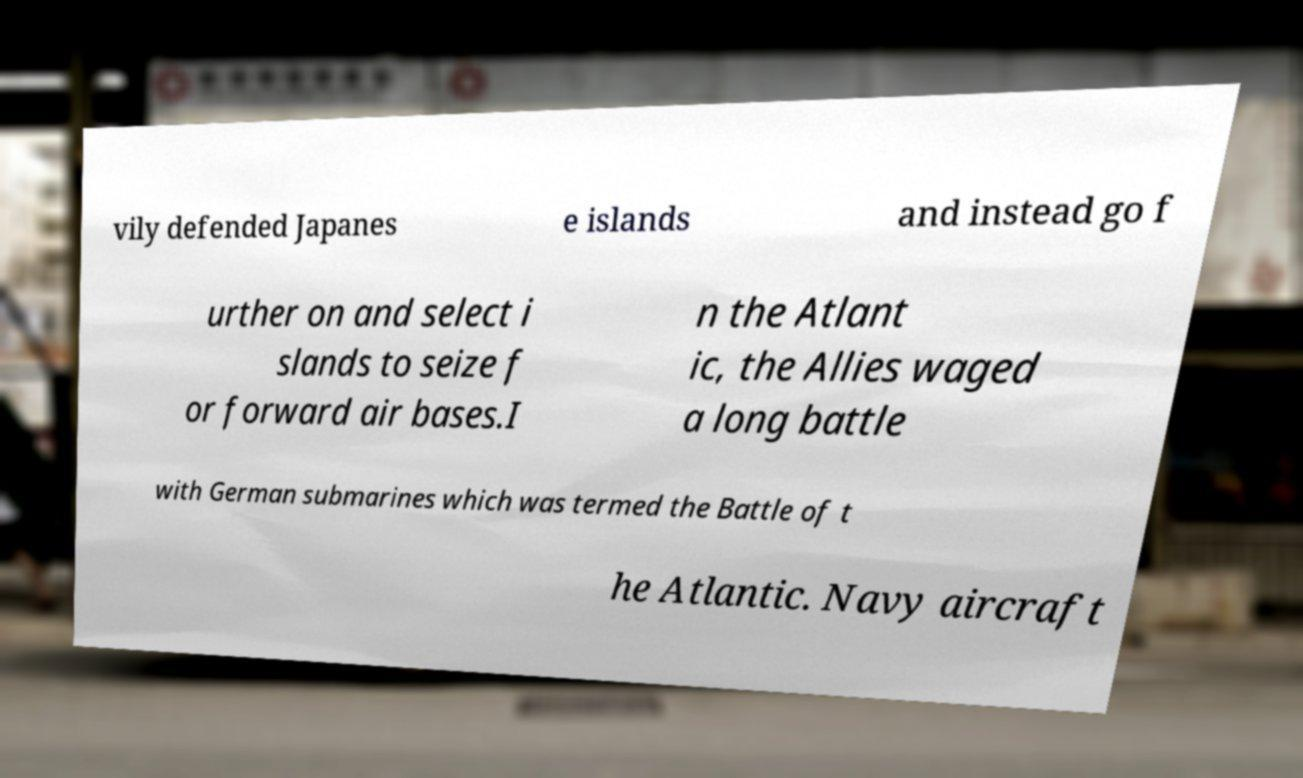For documentation purposes, I need the text within this image transcribed. Could you provide that? vily defended Japanes e islands and instead go f urther on and select i slands to seize f or forward air bases.I n the Atlant ic, the Allies waged a long battle with German submarines which was termed the Battle of t he Atlantic. Navy aircraft 